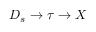<formula> <loc_0><loc_0><loc_500><loc_500>D _ { s } \to \tau \to X</formula> 